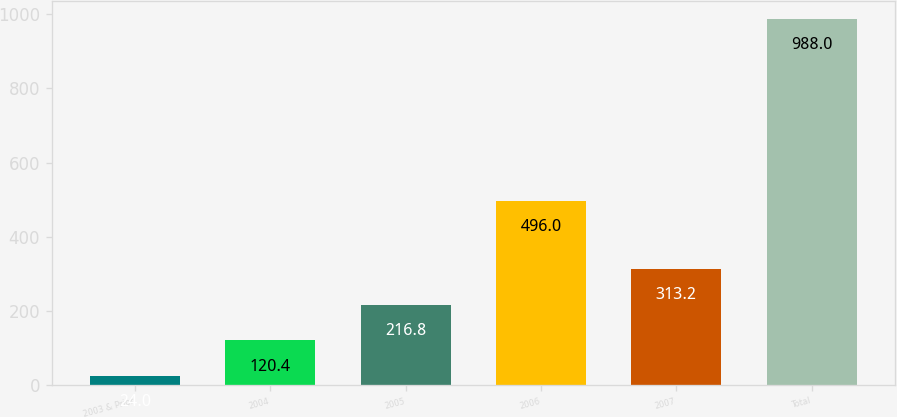Convert chart to OTSL. <chart><loc_0><loc_0><loc_500><loc_500><bar_chart><fcel>2003 & Prior<fcel>2004<fcel>2005<fcel>2006<fcel>2007<fcel>Total<nl><fcel>24<fcel>120.4<fcel>216.8<fcel>496<fcel>313.2<fcel>988<nl></chart> 